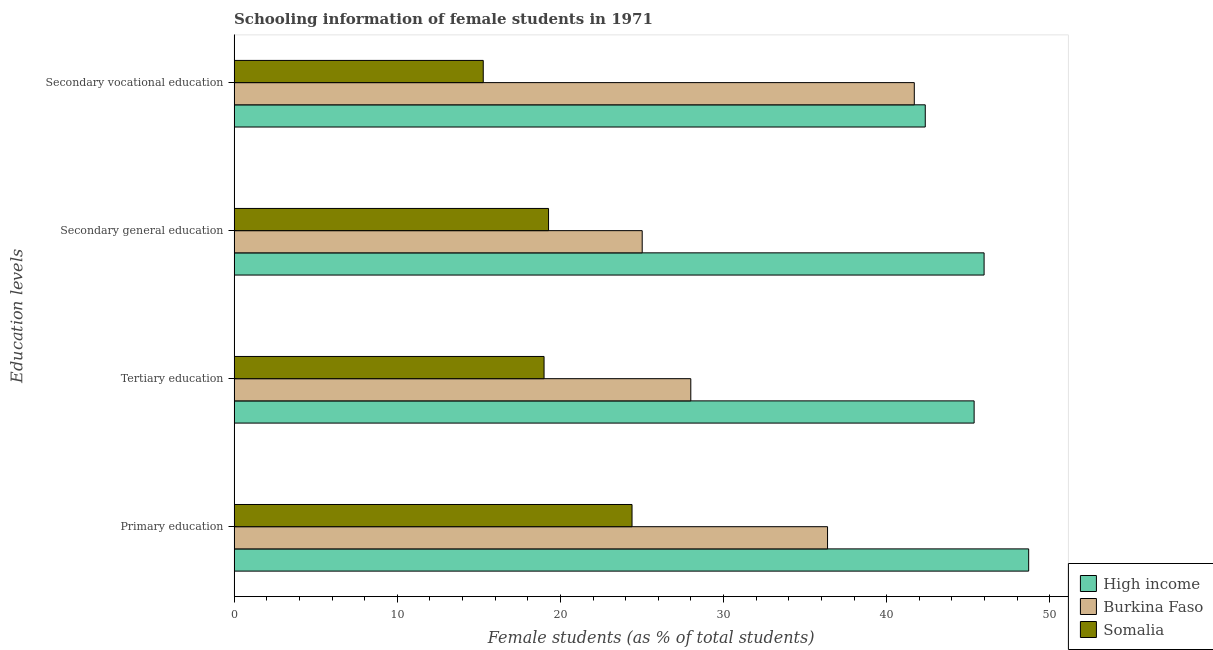How many different coloured bars are there?
Ensure brevity in your answer.  3. How many groups of bars are there?
Your response must be concise. 4. Are the number of bars per tick equal to the number of legend labels?
Offer a very short reply. Yes. Are the number of bars on each tick of the Y-axis equal?
Your answer should be compact. Yes. How many bars are there on the 4th tick from the bottom?
Your answer should be compact. 3. What is the label of the 3rd group of bars from the top?
Offer a very short reply. Tertiary education. What is the percentage of female students in tertiary education in Burkina Faso?
Ensure brevity in your answer.  27.99. Across all countries, what is the maximum percentage of female students in secondary vocational education?
Your answer should be very brief. 42.37. Across all countries, what is the minimum percentage of female students in secondary vocational education?
Offer a terse response. 15.27. In which country was the percentage of female students in primary education maximum?
Ensure brevity in your answer.  High income. In which country was the percentage of female students in tertiary education minimum?
Give a very brief answer. Somalia. What is the total percentage of female students in tertiary education in the graph?
Your response must be concise. 92.35. What is the difference between the percentage of female students in secondary education in High income and that in Burkina Faso?
Your answer should be very brief. 20.96. What is the difference between the percentage of female students in secondary vocational education in Somalia and the percentage of female students in tertiary education in High income?
Provide a short and direct response. -30.09. What is the average percentage of female students in primary education per country?
Your response must be concise. 36.49. What is the difference between the percentage of female students in secondary vocational education and percentage of female students in primary education in Somalia?
Your answer should be compact. -9.12. What is the ratio of the percentage of female students in secondary education in Somalia to that in Burkina Faso?
Offer a terse response. 0.77. Is the percentage of female students in secondary education in High income less than that in Burkina Faso?
Make the answer very short. No. What is the difference between the highest and the second highest percentage of female students in secondary education?
Keep it short and to the point. 20.96. What is the difference between the highest and the lowest percentage of female students in secondary education?
Your answer should be very brief. 26.7. Is the sum of the percentage of female students in secondary education in High income and Somalia greater than the maximum percentage of female students in secondary vocational education across all countries?
Ensure brevity in your answer.  Yes. What does the 1st bar from the top in Secondary vocational education represents?
Provide a succinct answer. Somalia. How many bars are there?
Provide a short and direct response. 12. Are all the bars in the graph horizontal?
Keep it short and to the point. Yes. How many countries are there in the graph?
Offer a very short reply. 3. What is the difference between two consecutive major ticks on the X-axis?
Your response must be concise. 10. Does the graph contain grids?
Ensure brevity in your answer.  No. How many legend labels are there?
Provide a short and direct response. 3. What is the title of the graph?
Keep it short and to the point. Schooling information of female students in 1971. Does "Bhutan" appear as one of the legend labels in the graph?
Ensure brevity in your answer.  No. What is the label or title of the X-axis?
Your answer should be very brief. Female students (as % of total students). What is the label or title of the Y-axis?
Your response must be concise. Education levels. What is the Female students (as % of total students) in High income in Primary education?
Make the answer very short. 48.7. What is the Female students (as % of total students) of Burkina Faso in Primary education?
Your response must be concise. 36.38. What is the Female students (as % of total students) in Somalia in Primary education?
Give a very brief answer. 24.39. What is the Female students (as % of total students) of High income in Tertiary education?
Offer a very short reply. 45.36. What is the Female students (as % of total students) in Burkina Faso in Tertiary education?
Your answer should be compact. 27.99. What is the Female students (as % of total students) of Somalia in Tertiary education?
Offer a terse response. 19. What is the Female students (as % of total students) of High income in Secondary general education?
Your answer should be very brief. 45.97. What is the Female students (as % of total students) of Burkina Faso in Secondary general education?
Offer a terse response. 25.01. What is the Female students (as % of total students) of Somalia in Secondary general education?
Provide a short and direct response. 19.27. What is the Female students (as % of total students) of High income in Secondary vocational education?
Provide a short and direct response. 42.37. What is the Female students (as % of total students) of Burkina Faso in Secondary vocational education?
Keep it short and to the point. 41.69. What is the Female students (as % of total students) in Somalia in Secondary vocational education?
Provide a succinct answer. 15.27. Across all Education levels, what is the maximum Female students (as % of total students) of High income?
Make the answer very short. 48.7. Across all Education levels, what is the maximum Female students (as % of total students) in Burkina Faso?
Give a very brief answer. 41.69. Across all Education levels, what is the maximum Female students (as % of total students) in Somalia?
Keep it short and to the point. 24.39. Across all Education levels, what is the minimum Female students (as % of total students) in High income?
Provide a short and direct response. 42.37. Across all Education levels, what is the minimum Female students (as % of total students) of Burkina Faso?
Your answer should be compact. 25.01. Across all Education levels, what is the minimum Female students (as % of total students) of Somalia?
Your answer should be compact. 15.27. What is the total Female students (as % of total students) in High income in the graph?
Offer a terse response. 182.4. What is the total Female students (as % of total students) of Burkina Faso in the graph?
Your response must be concise. 131.08. What is the total Female students (as % of total students) in Somalia in the graph?
Ensure brevity in your answer.  77.93. What is the difference between the Female students (as % of total students) in High income in Primary education and that in Tertiary education?
Make the answer very short. 3.34. What is the difference between the Female students (as % of total students) in Burkina Faso in Primary education and that in Tertiary education?
Your response must be concise. 8.38. What is the difference between the Female students (as % of total students) of Somalia in Primary education and that in Tertiary education?
Ensure brevity in your answer.  5.39. What is the difference between the Female students (as % of total students) of High income in Primary education and that in Secondary general education?
Your answer should be compact. 2.73. What is the difference between the Female students (as % of total students) in Burkina Faso in Primary education and that in Secondary general education?
Offer a very short reply. 11.36. What is the difference between the Female students (as % of total students) of Somalia in Primary education and that in Secondary general education?
Your answer should be compact. 5.12. What is the difference between the Female students (as % of total students) in High income in Primary education and that in Secondary vocational education?
Your answer should be very brief. 6.34. What is the difference between the Female students (as % of total students) in Burkina Faso in Primary education and that in Secondary vocational education?
Provide a short and direct response. -5.32. What is the difference between the Female students (as % of total students) of Somalia in Primary education and that in Secondary vocational education?
Keep it short and to the point. 9.12. What is the difference between the Female students (as % of total students) in High income in Tertiary education and that in Secondary general education?
Your response must be concise. -0.61. What is the difference between the Female students (as % of total students) of Burkina Faso in Tertiary education and that in Secondary general education?
Your answer should be very brief. 2.98. What is the difference between the Female students (as % of total students) in Somalia in Tertiary education and that in Secondary general education?
Ensure brevity in your answer.  -0.28. What is the difference between the Female students (as % of total students) in High income in Tertiary education and that in Secondary vocational education?
Offer a terse response. 3. What is the difference between the Female students (as % of total students) in Burkina Faso in Tertiary education and that in Secondary vocational education?
Your response must be concise. -13.7. What is the difference between the Female students (as % of total students) in Somalia in Tertiary education and that in Secondary vocational education?
Provide a short and direct response. 3.73. What is the difference between the Female students (as % of total students) in High income in Secondary general education and that in Secondary vocational education?
Provide a short and direct response. 3.61. What is the difference between the Female students (as % of total students) in Burkina Faso in Secondary general education and that in Secondary vocational education?
Your response must be concise. -16.68. What is the difference between the Female students (as % of total students) of Somalia in Secondary general education and that in Secondary vocational education?
Your response must be concise. 4. What is the difference between the Female students (as % of total students) of High income in Primary education and the Female students (as % of total students) of Burkina Faso in Tertiary education?
Provide a short and direct response. 20.71. What is the difference between the Female students (as % of total students) of High income in Primary education and the Female students (as % of total students) of Somalia in Tertiary education?
Keep it short and to the point. 29.71. What is the difference between the Female students (as % of total students) in Burkina Faso in Primary education and the Female students (as % of total students) in Somalia in Tertiary education?
Your response must be concise. 17.38. What is the difference between the Female students (as % of total students) of High income in Primary education and the Female students (as % of total students) of Burkina Faso in Secondary general education?
Make the answer very short. 23.69. What is the difference between the Female students (as % of total students) in High income in Primary education and the Female students (as % of total students) in Somalia in Secondary general education?
Offer a terse response. 29.43. What is the difference between the Female students (as % of total students) in Burkina Faso in Primary education and the Female students (as % of total students) in Somalia in Secondary general education?
Make the answer very short. 17.1. What is the difference between the Female students (as % of total students) in High income in Primary education and the Female students (as % of total students) in Burkina Faso in Secondary vocational education?
Provide a short and direct response. 7.01. What is the difference between the Female students (as % of total students) in High income in Primary education and the Female students (as % of total students) in Somalia in Secondary vocational education?
Your answer should be compact. 33.43. What is the difference between the Female students (as % of total students) in Burkina Faso in Primary education and the Female students (as % of total students) in Somalia in Secondary vocational education?
Give a very brief answer. 21.1. What is the difference between the Female students (as % of total students) of High income in Tertiary education and the Female students (as % of total students) of Burkina Faso in Secondary general education?
Your response must be concise. 20.35. What is the difference between the Female students (as % of total students) in High income in Tertiary education and the Female students (as % of total students) in Somalia in Secondary general education?
Your answer should be very brief. 26.09. What is the difference between the Female students (as % of total students) of Burkina Faso in Tertiary education and the Female students (as % of total students) of Somalia in Secondary general education?
Offer a very short reply. 8.72. What is the difference between the Female students (as % of total students) in High income in Tertiary education and the Female students (as % of total students) in Burkina Faso in Secondary vocational education?
Your answer should be very brief. 3.67. What is the difference between the Female students (as % of total students) of High income in Tertiary education and the Female students (as % of total students) of Somalia in Secondary vocational education?
Give a very brief answer. 30.09. What is the difference between the Female students (as % of total students) of Burkina Faso in Tertiary education and the Female students (as % of total students) of Somalia in Secondary vocational education?
Your response must be concise. 12.72. What is the difference between the Female students (as % of total students) of High income in Secondary general education and the Female students (as % of total students) of Burkina Faso in Secondary vocational education?
Your answer should be compact. 4.28. What is the difference between the Female students (as % of total students) in High income in Secondary general education and the Female students (as % of total students) in Somalia in Secondary vocational education?
Offer a very short reply. 30.7. What is the difference between the Female students (as % of total students) in Burkina Faso in Secondary general education and the Female students (as % of total students) in Somalia in Secondary vocational education?
Make the answer very short. 9.74. What is the average Female students (as % of total students) of High income per Education levels?
Provide a succinct answer. 45.6. What is the average Female students (as % of total students) of Burkina Faso per Education levels?
Your answer should be very brief. 32.77. What is the average Female students (as % of total students) in Somalia per Education levels?
Provide a succinct answer. 19.48. What is the difference between the Female students (as % of total students) of High income and Female students (as % of total students) of Burkina Faso in Primary education?
Provide a succinct answer. 12.33. What is the difference between the Female students (as % of total students) in High income and Female students (as % of total students) in Somalia in Primary education?
Keep it short and to the point. 24.31. What is the difference between the Female students (as % of total students) in Burkina Faso and Female students (as % of total students) in Somalia in Primary education?
Your response must be concise. 11.98. What is the difference between the Female students (as % of total students) of High income and Female students (as % of total students) of Burkina Faso in Tertiary education?
Make the answer very short. 17.37. What is the difference between the Female students (as % of total students) of High income and Female students (as % of total students) of Somalia in Tertiary education?
Offer a terse response. 26.36. What is the difference between the Female students (as % of total students) in Burkina Faso and Female students (as % of total students) in Somalia in Tertiary education?
Provide a short and direct response. 8.99. What is the difference between the Female students (as % of total students) in High income and Female students (as % of total students) in Burkina Faso in Secondary general education?
Make the answer very short. 20.96. What is the difference between the Female students (as % of total students) of High income and Female students (as % of total students) of Somalia in Secondary general education?
Provide a succinct answer. 26.7. What is the difference between the Female students (as % of total students) of Burkina Faso and Female students (as % of total students) of Somalia in Secondary general education?
Offer a very short reply. 5.74. What is the difference between the Female students (as % of total students) of High income and Female students (as % of total students) of Burkina Faso in Secondary vocational education?
Offer a terse response. 0.67. What is the difference between the Female students (as % of total students) in High income and Female students (as % of total students) in Somalia in Secondary vocational education?
Your response must be concise. 27.09. What is the difference between the Female students (as % of total students) in Burkina Faso and Female students (as % of total students) in Somalia in Secondary vocational education?
Your answer should be compact. 26.42. What is the ratio of the Female students (as % of total students) in High income in Primary education to that in Tertiary education?
Give a very brief answer. 1.07. What is the ratio of the Female students (as % of total students) of Burkina Faso in Primary education to that in Tertiary education?
Give a very brief answer. 1.3. What is the ratio of the Female students (as % of total students) in Somalia in Primary education to that in Tertiary education?
Your answer should be compact. 1.28. What is the ratio of the Female students (as % of total students) of High income in Primary education to that in Secondary general education?
Give a very brief answer. 1.06. What is the ratio of the Female students (as % of total students) in Burkina Faso in Primary education to that in Secondary general education?
Offer a very short reply. 1.45. What is the ratio of the Female students (as % of total students) in Somalia in Primary education to that in Secondary general education?
Your response must be concise. 1.27. What is the ratio of the Female students (as % of total students) in High income in Primary education to that in Secondary vocational education?
Your answer should be very brief. 1.15. What is the ratio of the Female students (as % of total students) of Burkina Faso in Primary education to that in Secondary vocational education?
Provide a short and direct response. 0.87. What is the ratio of the Female students (as % of total students) of Somalia in Primary education to that in Secondary vocational education?
Ensure brevity in your answer.  1.6. What is the ratio of the Female students (as % of total students) in High income in Tertiary education to that in Secondary general education?
Give a very brief answer. 0.99. What is the ratio of the Female students (as % of total students) in Burkina Faso in Tertiary education to that in Secondary general education?
Offer a terse response. 1.12. What is the ratio of the Female students (as % of total students) in Somalia in Tertiary education to that in Secondary general education?
Make the answer very short. 0.99. What is the ratio of the Female students (as % of total students) of High income in Tertiary education to that in Secondary vocational education?
Give a very brief answer. 1.07. What is the ratio of the Female students (as % of total students) in Burkina Faso in Tertiary education to that in Secondary vocational education?
Provide a short and direct response. 0.67. What is the ratio of the Female students (as % of total students) of Somalia in Tertiary education to that in Secondary vocational education?
Give a very brief answer. 1.24. What is the ratio of the Female students (as % of total students) of High income in Secondary general education to that in Secondary vocational education?
Ensure brevity in your answer.  1.09. What is the ratio of the Female students (as % of total students) in Somalia in Secondary general education to that in Secondary vocational education?
Give a very brief answer. 1.26. What is the difference between the highest and the second highest Female students (as % of total students) in High income?
Keep it short and to the point. 2.73. What is the difference between the highest and the second highest Female students (as % of total students) in Burkina Faso?
Ensure brevity in your answer.  5.32. What is the difference between the highest and the second highest Female students (as % of total students) in Somalia?
Your answer should be very brief. 5.12. What is the difference between the highest and the lowest Female students (as % of total students) of High income?
Make the answer very short. 6.34. What is the difference between the highest and the lowest Female students (as % of total students) in Burkina Faso?
Offer a very short reply. 16.68. What is the difference between the highest and the lowest Female students (as % of total students) in Somalia?
Offer a very short reply. 9.12. 